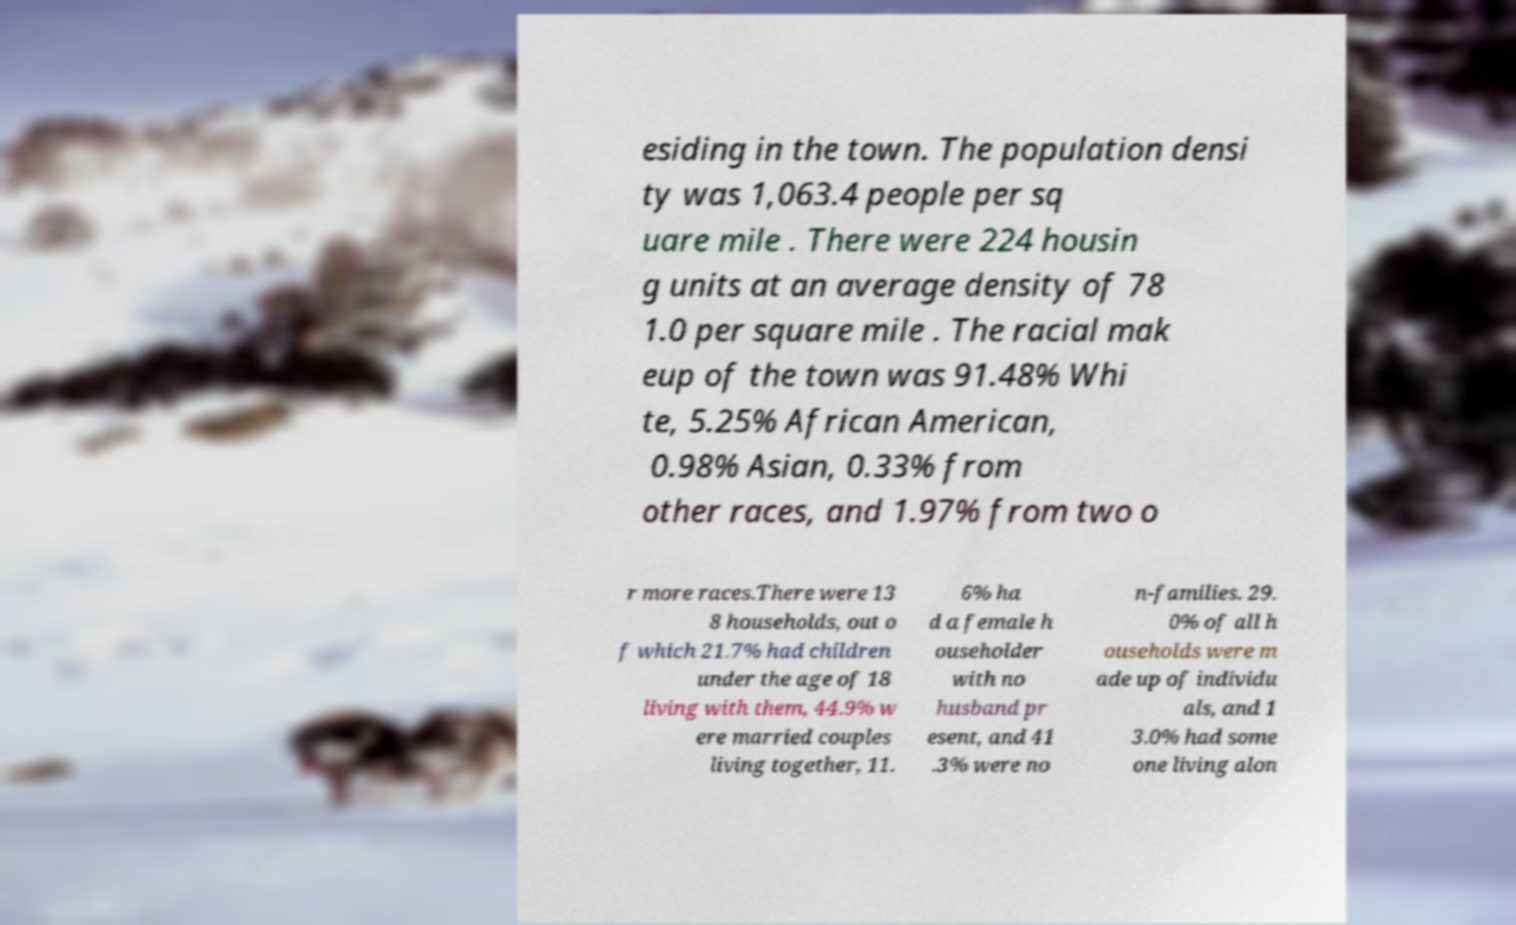Could you extract and type out the text from this image? esiding in the town. The population densi ty was 1,063.4 people per sq uare mile . There were 224 housin g units at an average density of 78 1.0 per square mile . The racial mak eup of the town was 91.48% Whi te, 5.25% African American, 0.98% Asian, 0.33% from other races, and 1.97% from two o r more races.There were 13 8 households, out o f which 21.7% had children under the age of 18 living with them, 44.9% w ere married couples living together, 11. 6% ha d a female h ouseholder with no husband pr esent, and 41 .3% were no n-families. 29. 0% of all h ouseholds were m ade up of individu als, and 1 3.0% had some one living alon 